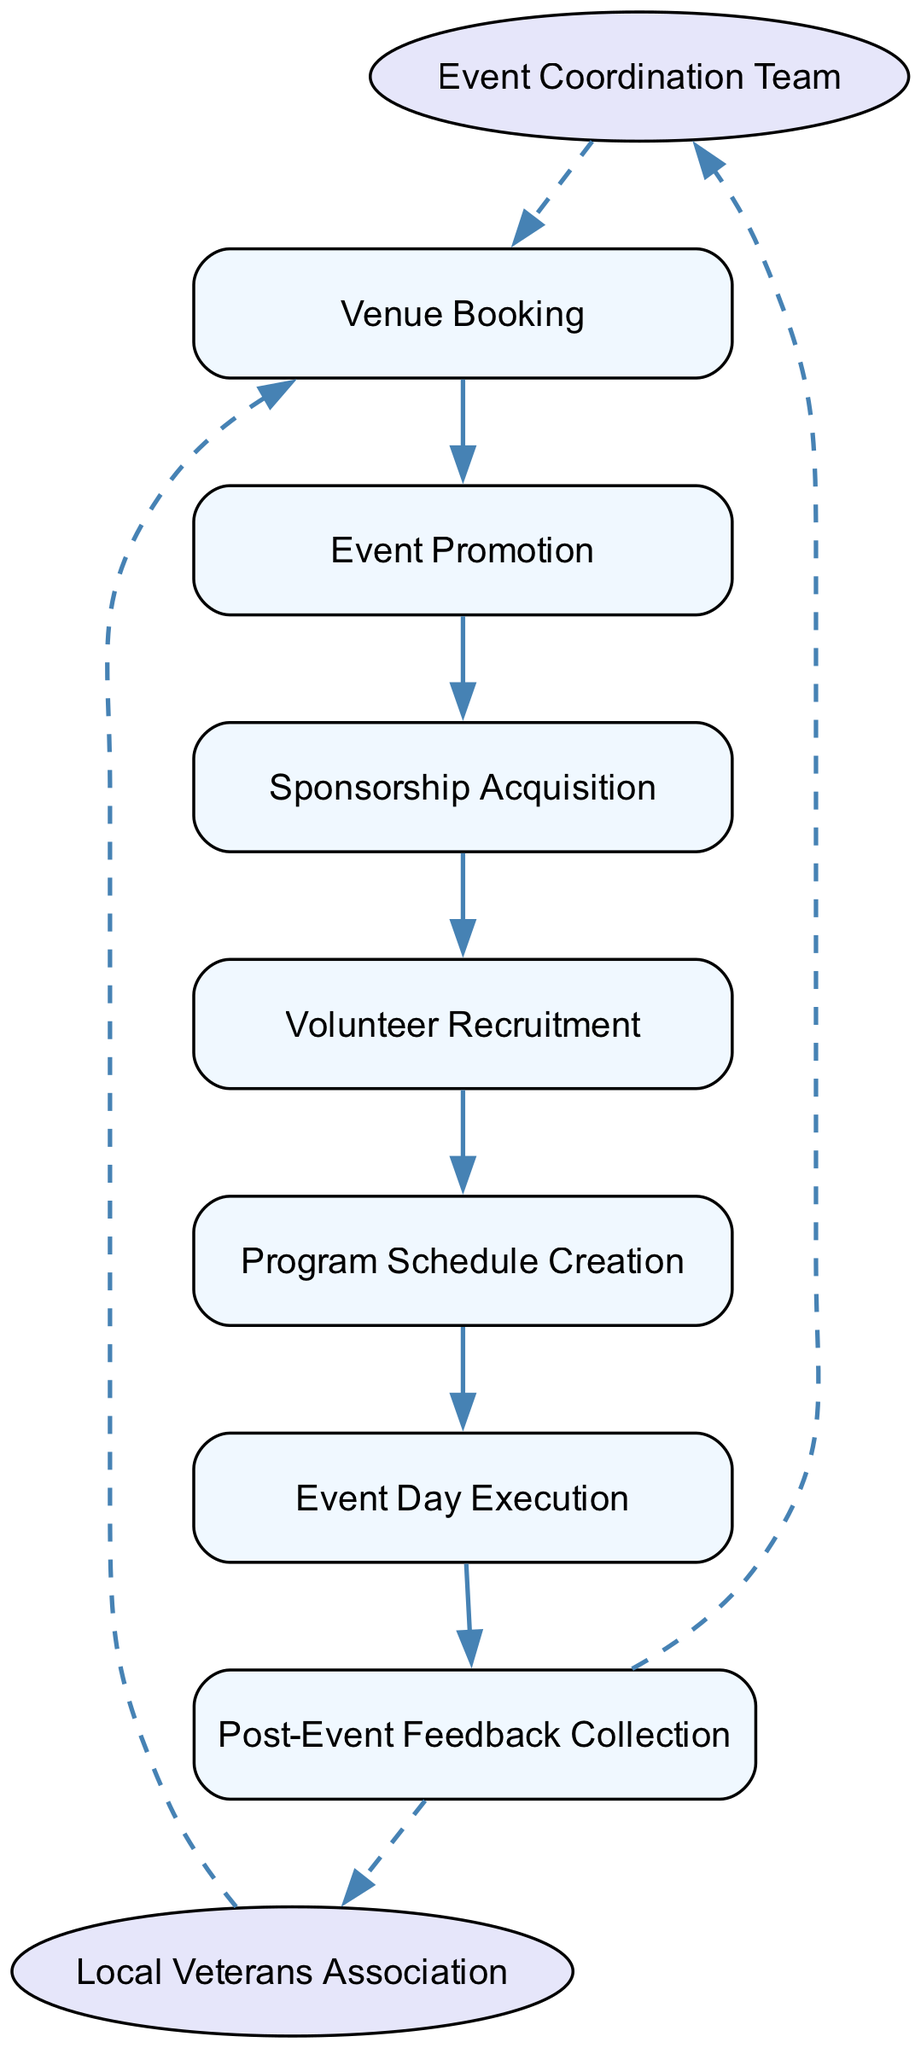What is the first action in the event timeline? The diagram indicates that the first action node is "Venue Booking," which starts the sequence of activities planned for the veterans' event.
Answer: Venue Booking How many organizations are involved in the diagram? The diagram includes two organizations: the "Event Coordination Team" and the "Local Veterans Association," each represented by a unique node.
Answer: 2 What is the last action in the sequence? The diagram shows that the final action listed is "Post-Event Feedback Collection," which follows the execution of the event and concludes the timeline.
Answer: Post-Event Feedback Collection Which action connects directly to the "Event Promotion"? Following the sequence in the diagram, "Volunteer Recruitment" is the action that is immediately after "Event Promotion," indicating a direct connection in the timeline of tasks.
Answer: Volunteer Recruitment What type of communication line connects the organizations to the actions? The organizations have dashed lines that symbolize their connection to the action nodes, indicating a supportive and non-direct engagement in the workflow of the event planning.
Answer: Dashed lines Explain the flow from "Sponsorship Acquisition" to "Event Day Execution". The flow starts with "Sponsorship Acquisition," which is completed before "Program Schedule Creation." After the schedule is made, the next action is "Event Day Execution," which indicates that securing sponsorship is a prerequisite for the scheduling of the event, ultimately leading to the execution of activities on the event day.
Answer: Sponsorship Acquisition → Program Schedule Creation → Event Day Execution How many actions are listed in total? The diagram features a total of eight action nodes that represent various activities involved in coordinating the veterans’ event, showing the comprehensive process from start to finish.
Answer: 8 Which organization is responsible for planning the event? The "Event Coordination Team" is identified in the diagram as the organization tasked with the overall planning of the veterans' event, which coordinates all the actions required.
Answer: Event Coordination Team What is the purpose of the dashed lines in the diagram? The dashed lines illustrate a supportive relationship between the organizations and the actions, highlighting how these entities contribute without being directly involved in the sequence of actions themselves.
Answer: Supportive relationship 